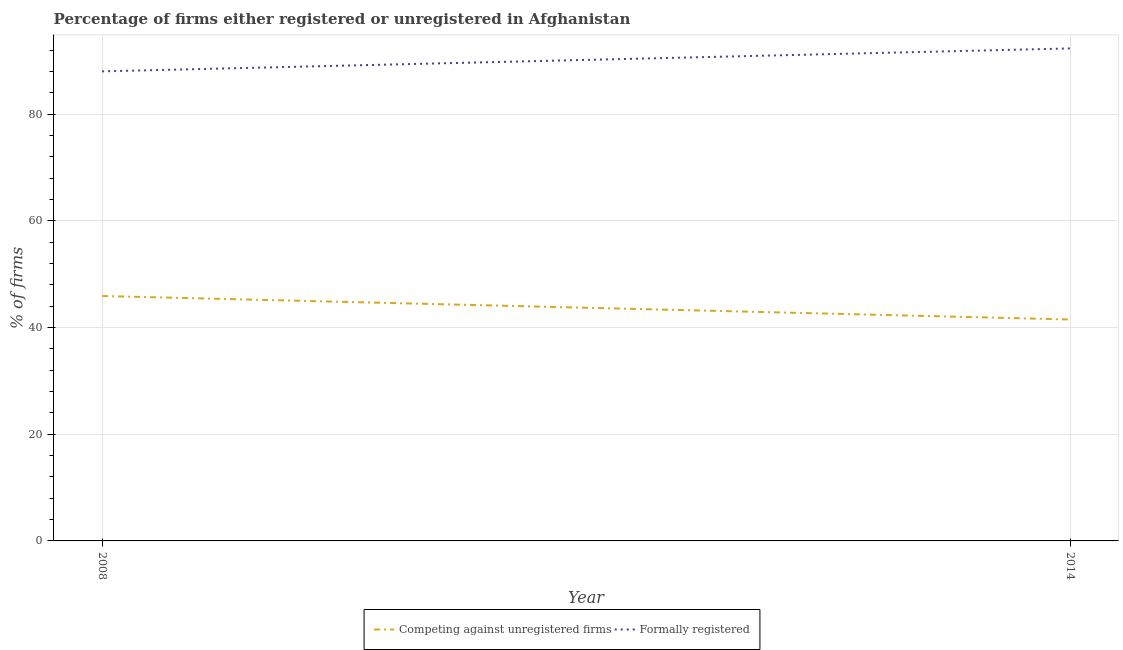Does the line corresponding to percentage of registered firms intersect with the line corresponding to percentage of formally registered firms?
Your response must be concise. No. What is the percentage of formally registered firms in 2008?
Your answer should be compact. 88. Across all years, what is the maximum percentage of registered firms?
Your answer should be compact. 45.9. In which year was the percentage of registered firms maximum?
Ensure brevity in your answer.  2008. What is the total percentage of registered firms in the graph?
Your response must be concise. 87.4. What is the difference between the percentage of formally registered firms in 2008 and that in 2014?
Offer a very short reply. -4.3. What is the difference between the percentage of registered firms in 2008 and the percentage of formally registered firms in 2014?
Your answer should be very brief. -46.4. What is the average percentage of registered firms per year?
Give a very brief answer. 43.7. In the year 2008, what is the difference between the percentage of registered firms and percentage of formally registered firms?
Your answer should be very brief. -42.1. In how many years, is the percentage of formally registered firms greater than 40 %?
Keep it short and to the point. 2. What is the ratio of the percentage of formally registered firms in 2008 to that in 2014?
Give a very brief answer. 0.95. Is the percentage of formally registered firms in 2008 less than that in 2014?
Keep it short and to the point. Yes. What is the difference between two consecutive major ticks on the Y-axis?
Your answer should be very brief. 20. Are the values on the major ticks of Y-axis written in scientific E-notation?
Ensure brevity in your answer.  No. What is the title of the graph?
Ensure brevity in your answer.  Percentage of firms either registered or unregistered in Afghanistan. Does "Money lenders" appear as one of the legend labels in the graph?
Offer a terse response. No. What is the label or title of the X-axis?
Ensure brevity in your answer.  Year. What is the label or title of the Y-axis?
Make the answer very short. % of firms. What is the % of firms in Competing against unregistered firms in 2008?
Provide a succinct answer. 45.9. What is the % of firms of Formally registered in 2008?
Your answer should be compact. 88. What is the % of firms of Competing against unregistered firms in 2014?
Offer a very short reply. 41.5. What is the % of firms in Formally registered in 2014?
Keep it short and to the point. 92.3. Across all years, what is the maximum % of firms in Competing against unregistered firms?
Your response must be concise. 45.9. Across all years, what is the maximum % of firms of Formally registered?
Offer a very short reply. 92.3. Across all years, what is the minimum % of firms of Competing against unregistered firms?
Provide a short and direct response. 41.5. Across all years, what is the minimum % of firms in Formally registered?
Make the answer very short. 88. What is the total % of firms of Competing against unregistered firms in the graph?
Your answer should be compact. 87.4. What is the total % of firms in Formally registered in the graph?
Provide a short and direct response. 180.3. What is the difference between the % of firms in Competing against unregistered firms in 2008 and that in 2014?
Give a very brief answer. 4.4. What is the difference between the % of firms in Competing against unregistered firms in 2008 and the % of firms in Formally registered in 2014?
Give a very brief answer. -46.4. What is the average % of firms in Competing against unregistered firms per year?
Ensure brevity in your answer.  43.7. What is the average % of firms in Formally registered per year?
Make the answer very short. 90.15. In the year 2008, what is the difference between the % of firms in Competing against unregistered firms and % of firms in Formally registered?
Provide a short and direct response. -42.1. In the year 2014, what is the difference between the % of firms in Competing against unregistered firms and % of firms in Formally registered?
Keep it short and to the point. -50.8. What is the ratio of the % of firms of Competing against unregistered firms in 2008 to that in 2014?
Make the answer very short. 1.11. What is the ratio of the % of firms of Formally registered in 2008 to that in 2014?
Provide a short and direct response. 0.95. What is the difference between the highest and the lowest % of firms in Competing against unregistered firms?
Provide a succinct answer. 4.4. 